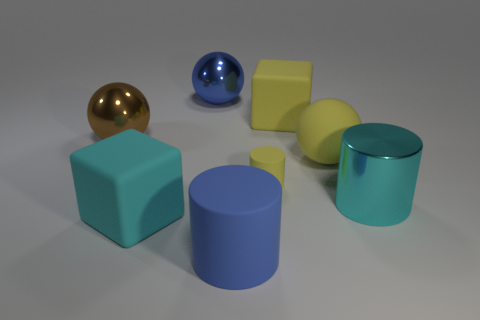Subtract all big blue metal spheres. How many spheres are left? 2 Add 1 big metal balls. How many objects exist? 9 Subtract 1 cylinders. How many cylinders are left? 2 Subtract all blocks. How many objects are left? 6 Subtract all red balls. Subtract all yellow cylinders. How many balls are left? 3 Add 8 big green shiny balls. How many big green shiny balls exist? 8 Subtract 1 cyan blocks. How many objects are left? 7 Subtract all big metallic objects. Subtract all small cyan metal spheres. How many objects are left? 5 Add 4 yellow rubber blocks. How many yellow rubber blocks are left? 5 